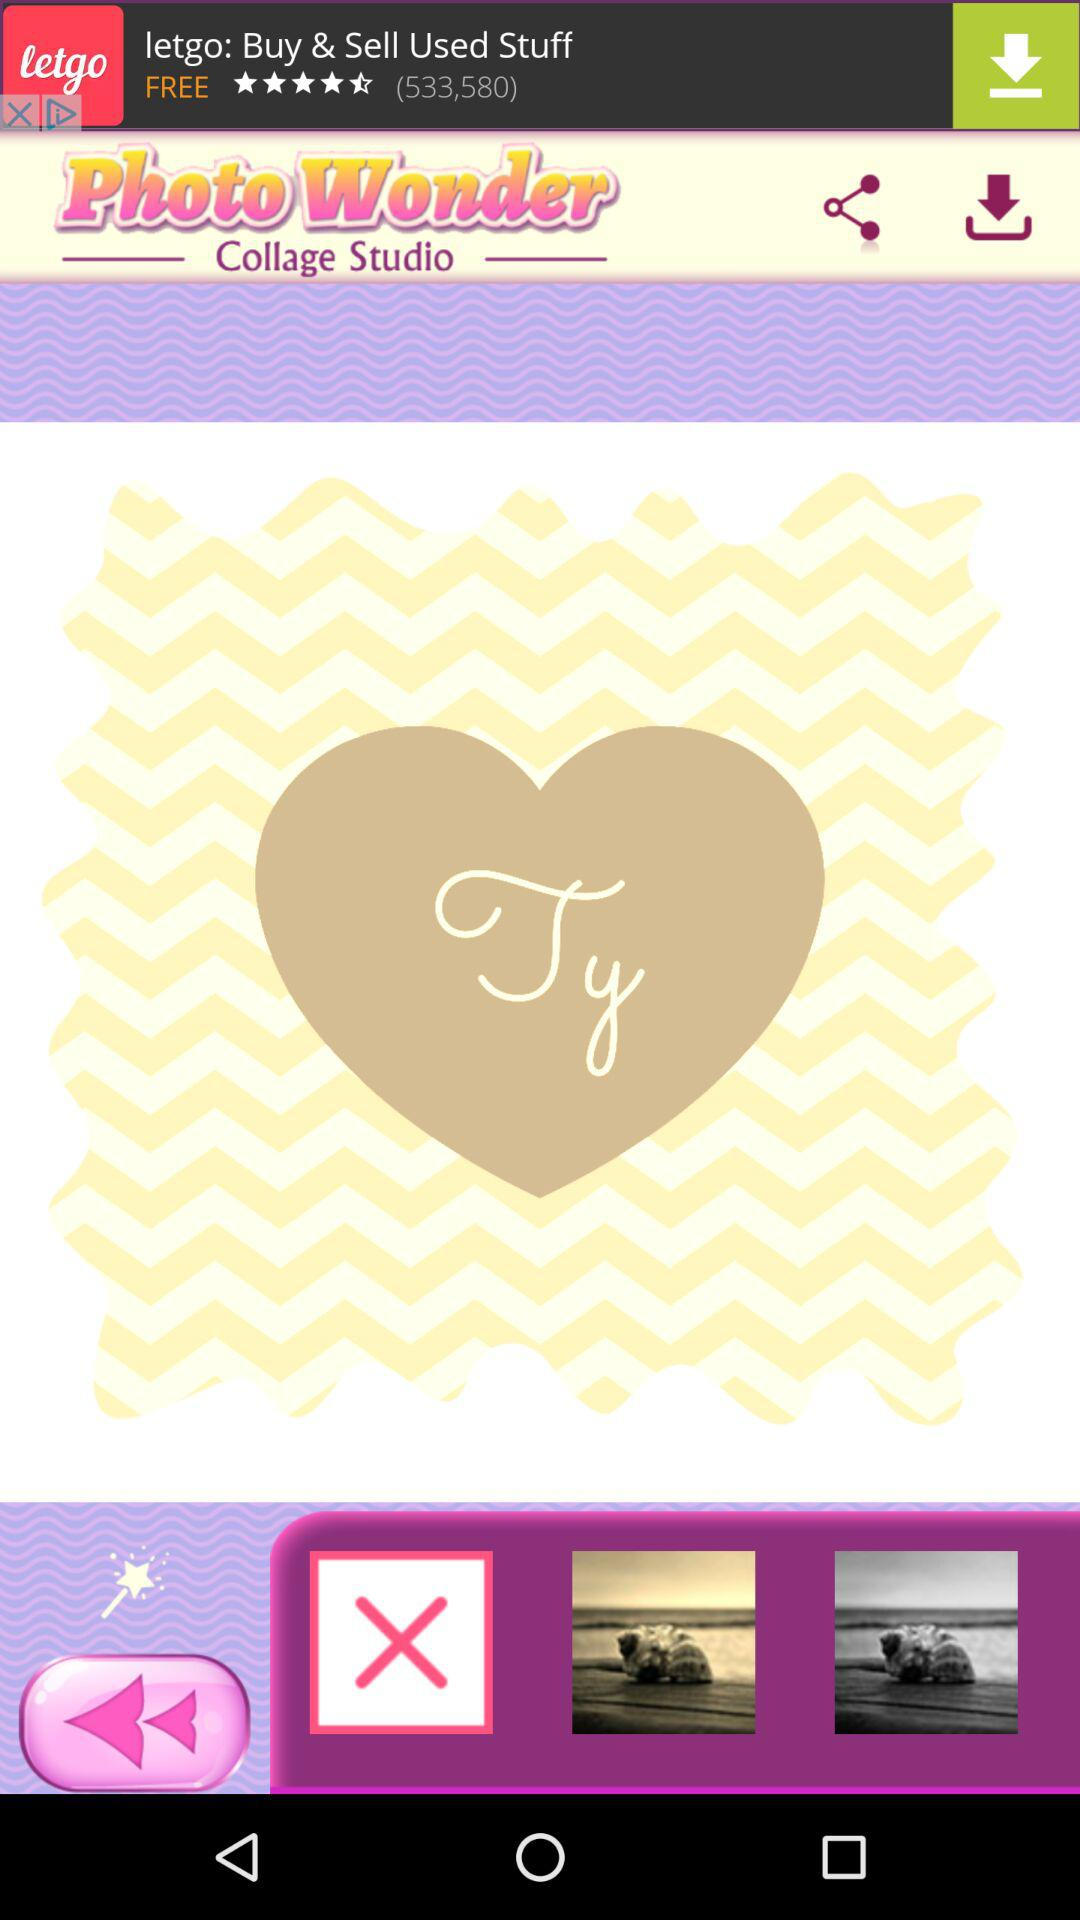What is the application name? The application name is "Photo Wonder". 